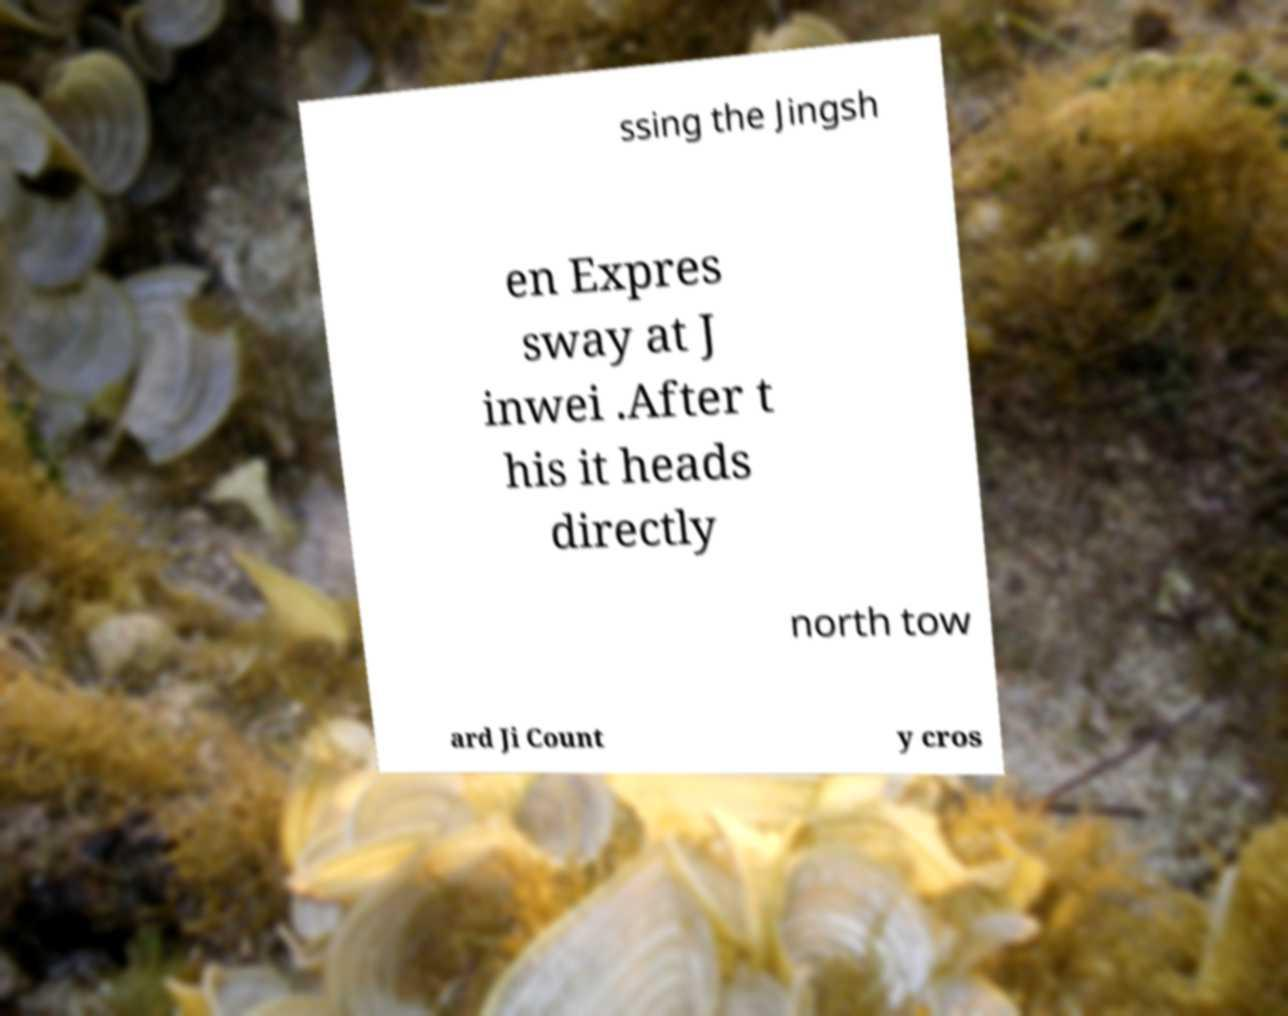Can you accurately transcribe the text from the provided image for me? ssing the Jingsh en Expres sway at J inwei .After t his it heads directly north tow ard Ji Count y cros 